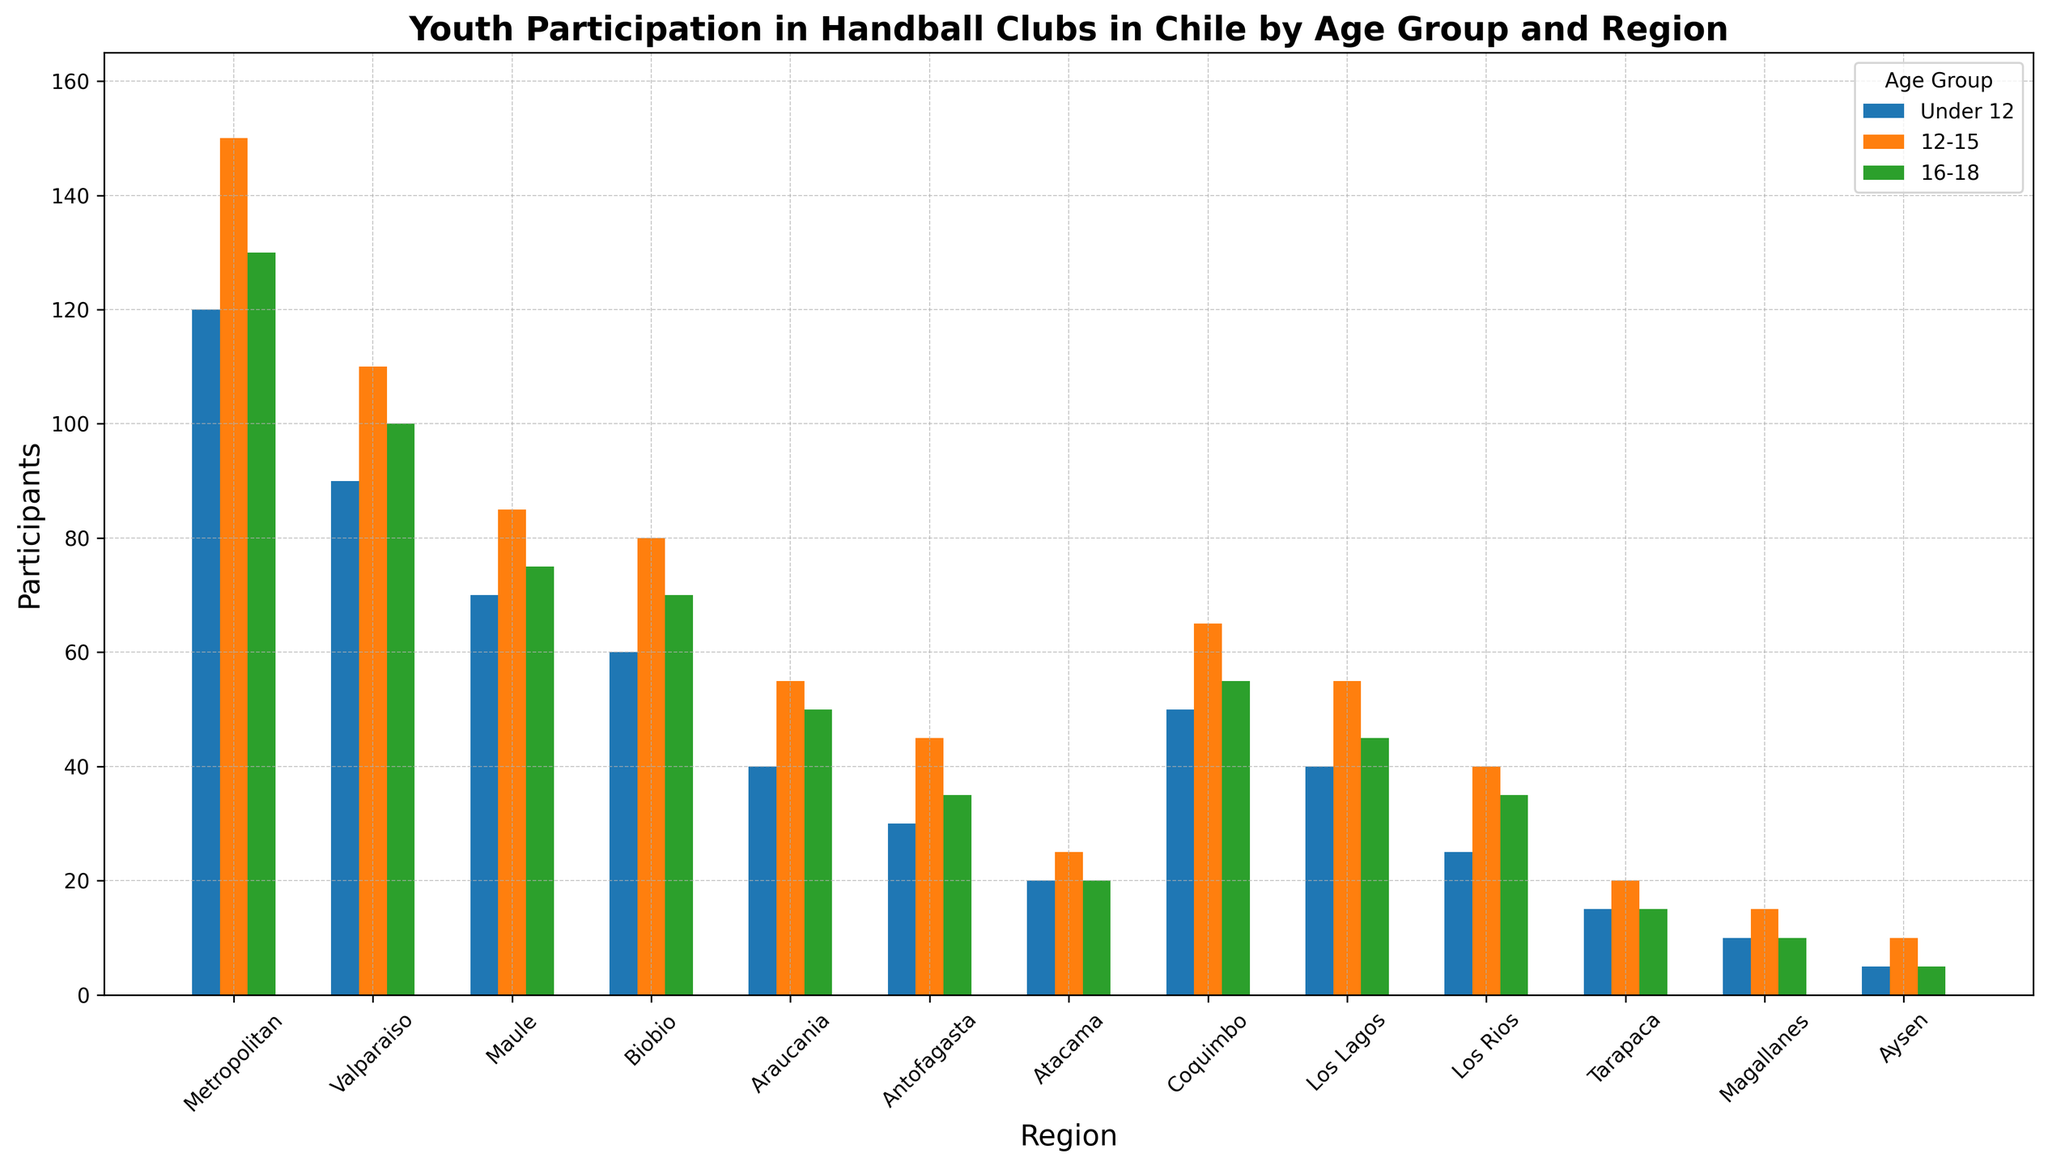Which region has the highest number of participants in the '16-18' age group? To find the region with the highest number of participants in the '16-18' age group, look for the tallest bar in the '16-18' age group. The Metropolitan region has the tallest bar, indicating the highest number of participants.
Answer: Metropolitan Which age group has the least participation in the Tarapaca region? To identify the age group with the least participation, compare the heights of the bars for the Tarapaca region. The 'Under 12' and '16-18' age groups have the lowest bars, indicating they have the least participation.
Answer: Under 12 and 16-18 How many total participants are there in the Valparaiso region across all age groups? Sum the number of participants for each age group in the Valparaiso region: 90 (Under 12) + 110 (12-15) + 100 (16-18). The total is 300 participants.
Answer: 300 What is the difference in participants between the '12-15' and 'Under 12' age groups in the Maule region? Subtract the number of participants in the 'Under 12' age group (70) from the '12-15' age group (85) in the Maule region: 85 - 70 = 15.
Answer: 15 Which region has a higher number of participants in the '12-15' age group, Biobio or Los Lagos? Compare the heights of the bars for the '12-15' age group in Biobio (80) and Los Lagos (55). The Biobio region has more participants.
Answer: Biobio What are the regions with fewer than 40 participants in the '16-18' age group? Look for the regions with bars shorter than 40 participants in the '16-18' age group. Antofagasta, Atacama, Los Rios, Tarapaca, Magallanes, and Aysen fall below 40 participants.
Answer: Antofagasta, Atacama, Los Rios, Tarapaca, Magallanes, Aysen Which age group generally has the highest participation across all regions? Compare the bars for each age group across all regions. Generally, the '12-15' age group has the highest participation since their bars are consistently higher in most regions.
Answer: 12-15 What is the average number of participants in the 'Under 12' age group for the Metropolitan, Valparaiso, and Maule regions? Add the number of participants in the 'Under 12' age group for the three regions and divide by 3: (120 + 90 + 70) / 3 = 280 / 3 = approximately 93.33.
Answer: ~93.33 Which age group in the Metropolitan region exceeds 100 participants by the greatest margin? Compare the number of participants in each age group of the Metropolitan region to 100. The '12-15' age group (150 participants) exceeds 100 by the greatest margin (50).
Answer: 12-15 Between the Antofagasta and Magallanes regions, which has a greater total number of participants across all age groups? Sum the number of participants across all age groups for both regions: Antofagasta (30 + 45 + 35 = 110) and Magallanes (10 + 15 + 10 = 35). Antofagasta has more participants.
Answer: Antofagasta 